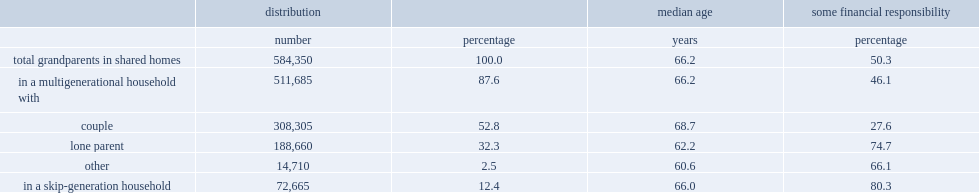What is the number and percentage of grandparents in a shared home with their grandchildren who also lived with one or more persons from the middle generation? 511685.0 87.6. Co-residing grandparents were more likely to live with a middle generation comprised of a couple or a lone parent? Couple. What percentage of co-residing grandparents lived with a middle generation comprised of either both a couple and a lone parent or a more complex combination? 2.5. How many grandparents aged 45 and over in a shared home were in a skip-generation household in 2011? 72665.0. What percentage of randparents aged 45 and over in a shared home were in a skip-generation household in 2011? 12.4. What percentage of grandparents in skip-generation households had responsibility for household payments? 80.3. What percentage of grandparents in multigenerational households with a lone-parent middle generation had responsibility for household payments? 74.7. When the middle generation was a couple, what percentage of grandparents contributed financially to household payments? 27.6. 